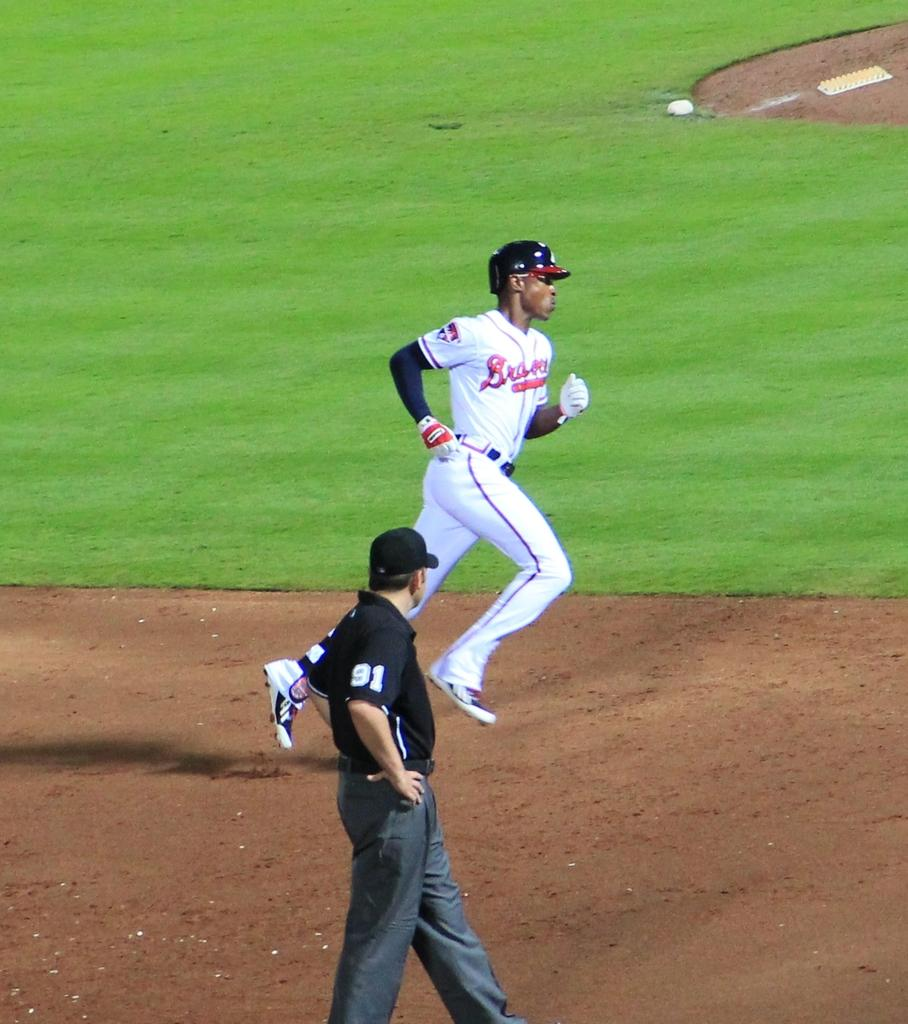<image>
Render a clear and concise summary of the photo. A baseball player for the Braves runs as a referee with a 91 on his sleeve watches. 